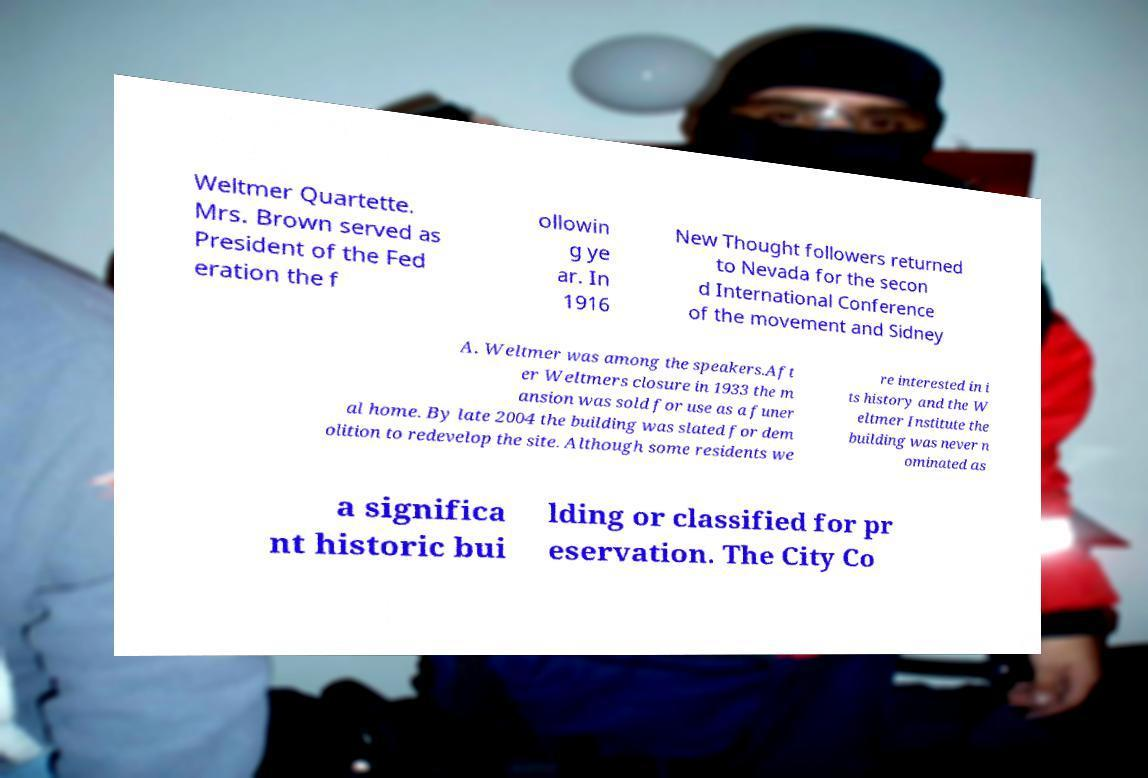Can you read and provide the text displayed in the image?This photo seems to have some interesting text. Can you extract and type it out for me? Weltmer Quartette. Mrs. Brown served as President of the Fed eration the f ollowin g ye ar. In 1916 New Thought followers returned to Nevada for the secon d International Conference of the movement and Sidney A. Weltmer was among the speakers.Aft er Weltmers closure in 1933 the m ansion was sold for use as a funer al home. By late 2004 the building was slated for dem olition to redevelop the site. Although some residents we re interested in i ts history and the W eltmer Institute the building was never n ominated as a significa nt historic bui lding or classified for pr eservation. The City Co 